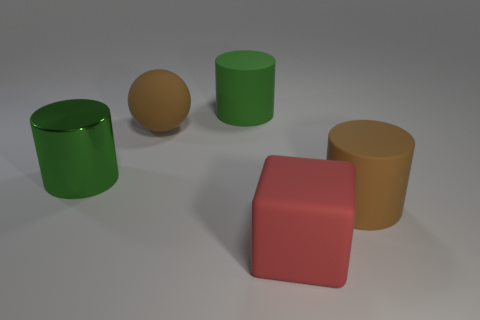How many big cylinders are to the right of the big green shiny object and in front of the big brown sphere?
Offer a terse response. 1. The object that is the same color as the large rubber ball is what shape?
Provide a succinct answer. Cylinder. The object that is right of the brown sphere and behind the green shiny cylinder is made of what material?
Provide a succinct answer. Rubber. Are there fewer green cylinders that are behind the big green shiny cylinder than green matte cylinders in front of the rubber ball?
Your response must be concise. No. There is a brown sphere that is the same material as the red object; what is its size?
Offer a very short reply. Large. Is there any other thing that is the same color as the big matte cube?
Keep it short and to the point. No. Are the ball and the brown thing on the right side of the big red cube made of the same material?
Your response must be concise. Yes. There is another brown object that is the same shape as the metallic object; what is its material?
Offer a very short reply. Rubber. Are there any other things that have the same material as the cube?
Give a very brief answer. Yes. Is the large object left of the sphere made of the same material as the large brown object left of the large red matte block?
Ensure brevity in your answer.  No. 